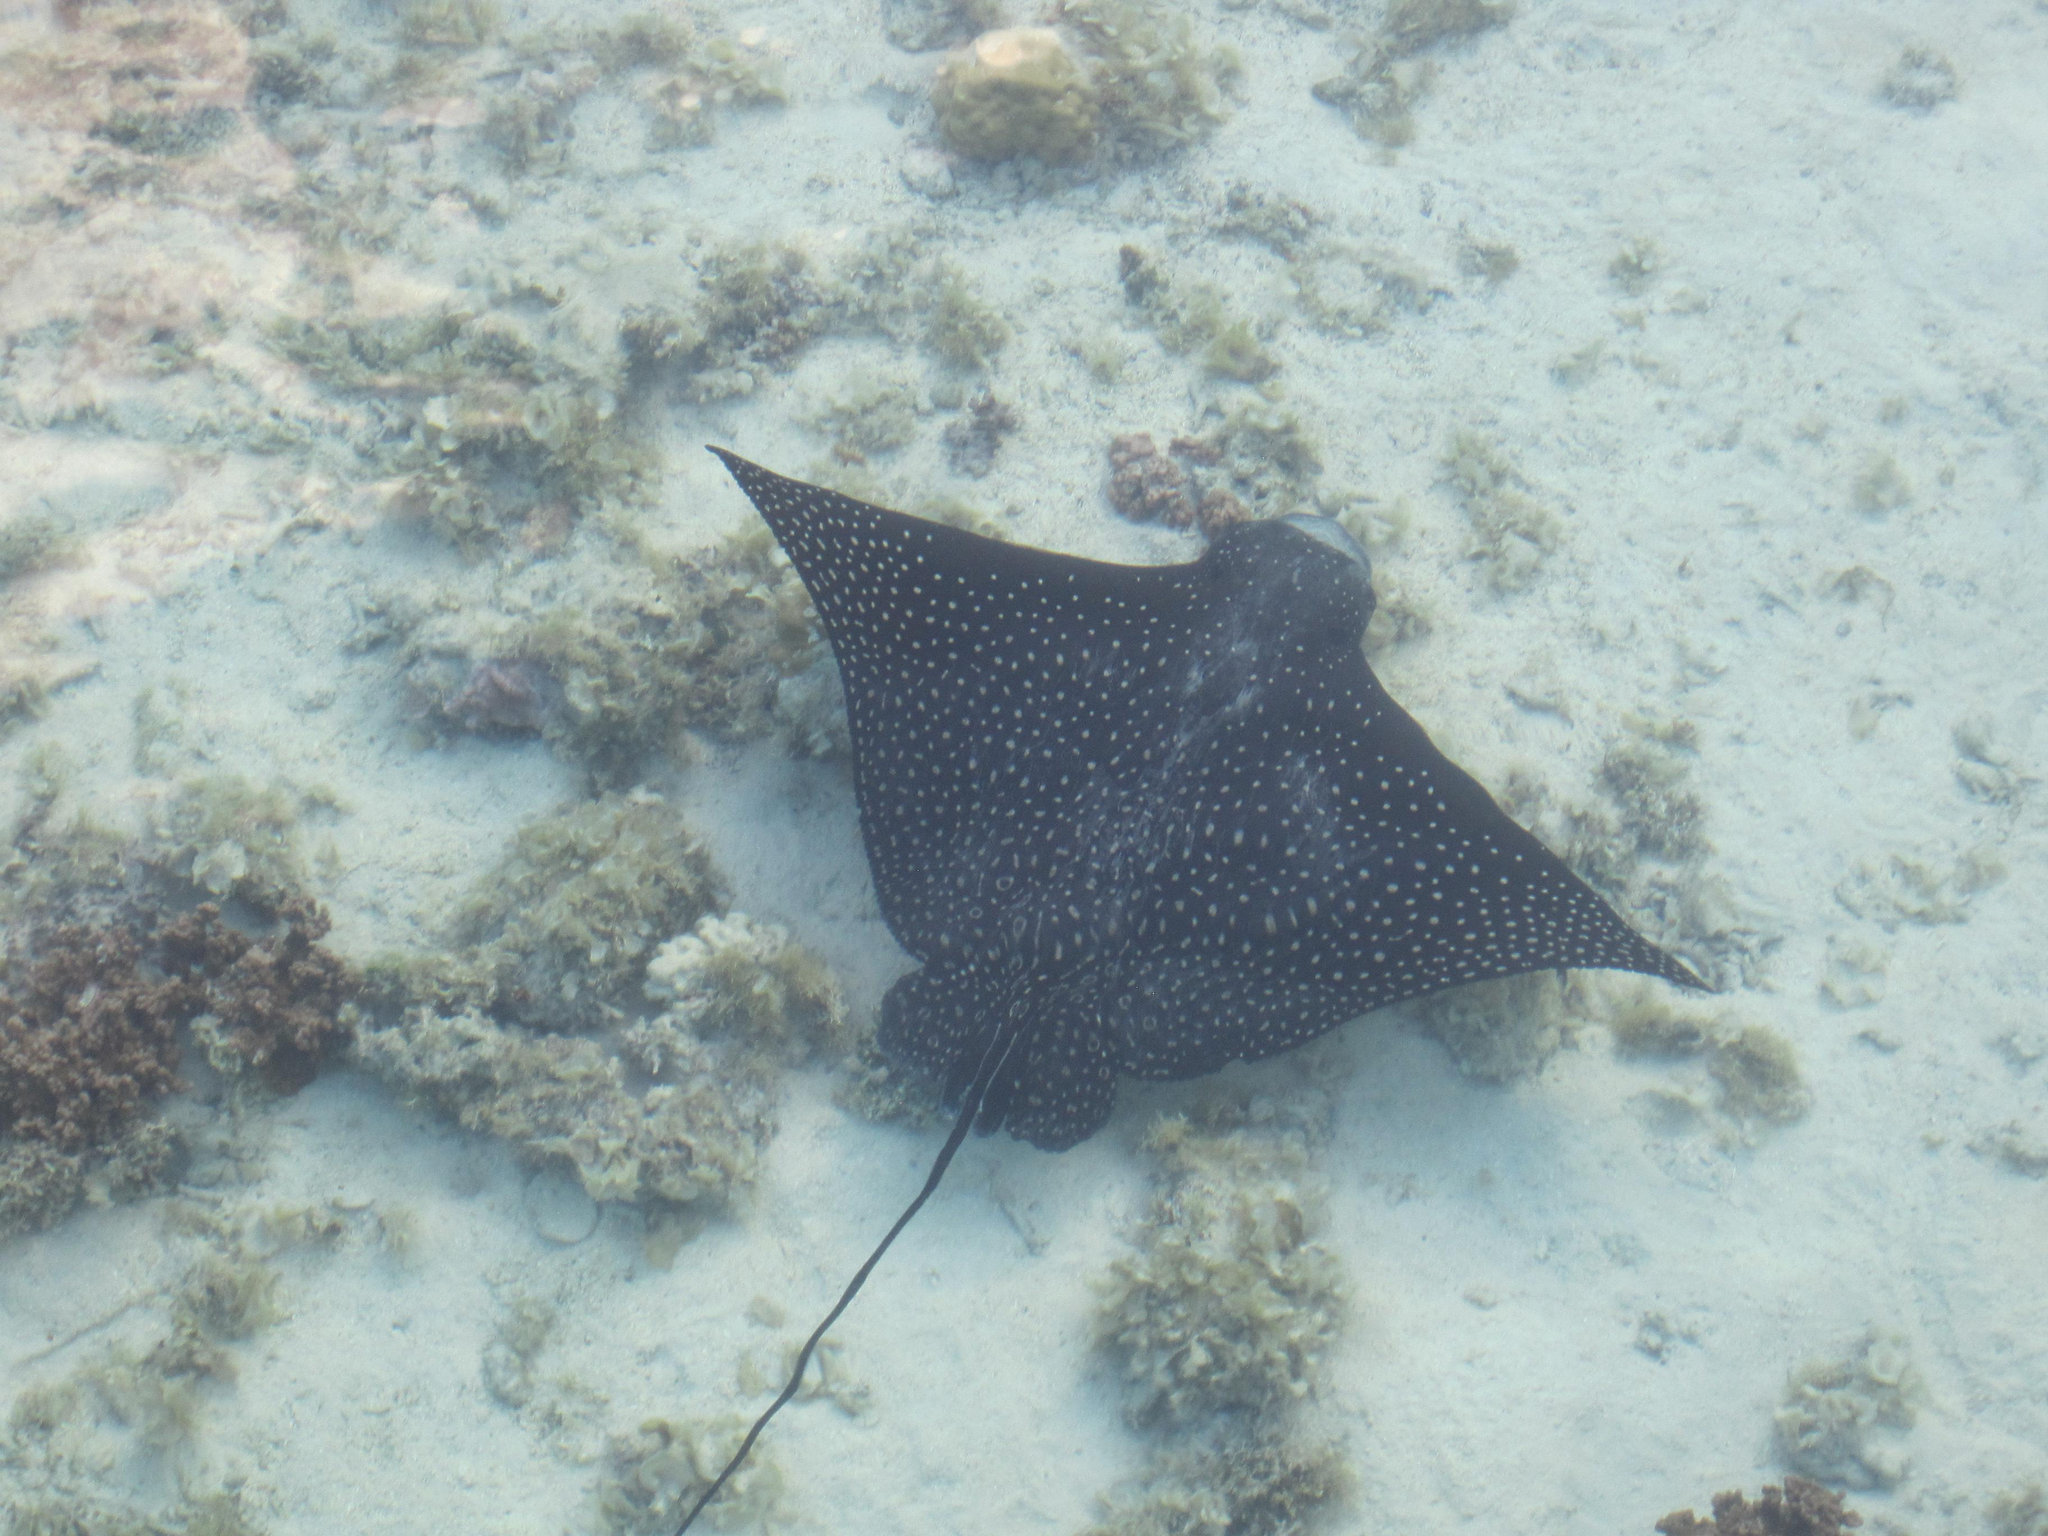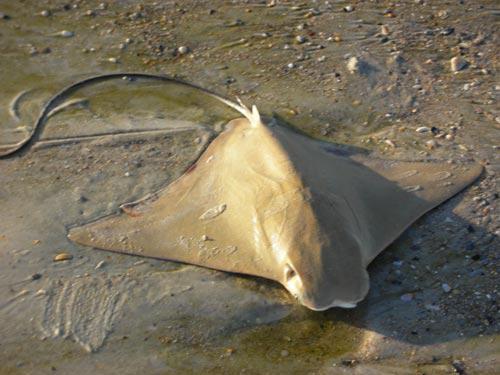The first image is the image on the left, the second image is the image on the right. Analyze the images presented: Is the assertion "An image shows one dark stingray with small pale dots." valid? Answer yes or no. Yes. 